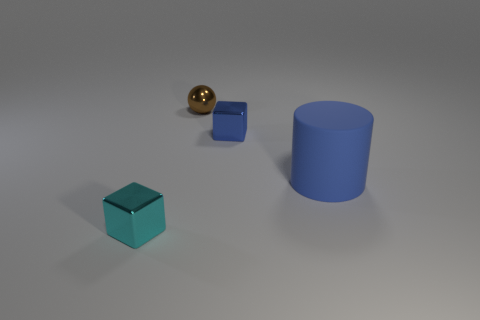Is there any other thing that has the same material as the big blue thing?
Your response must be concise. No. What number of things are to the right of the brown metal ball and left of the large blue rubber thing?
Make the answer very short. 1. There is a small object behind the small blue metallic object; what is its shape?
Your answer should be compact. Sphere. What number of objects have the same material as the blue cube?
Make the answer very short. 2. There is a blue metal thing; is it the same shape as the tiny metal object that is in front of the small blue thing?
Give a very brief answer. Yes. There is a small metallic block behind the cyan metallic cube left of the blue matte cylinder; is there a big blue rubber cylinder that is on the left side of it?
Keep it short and to the point. No. There is a blue thing behind the large object; what is its size?
Give a very brief answer. Small. Is the shape of the blue matte object the same as the cyan metallic thing?
Your answer should be very brief. No. What number of things are big red cubes or shiny blocks on the right side of the cyan object?
Your response must be concise. 1. There is a cube left of the brown ball; is its size the same as the small blue shiny object?
Ensure brevity in your answer.  Yes. 